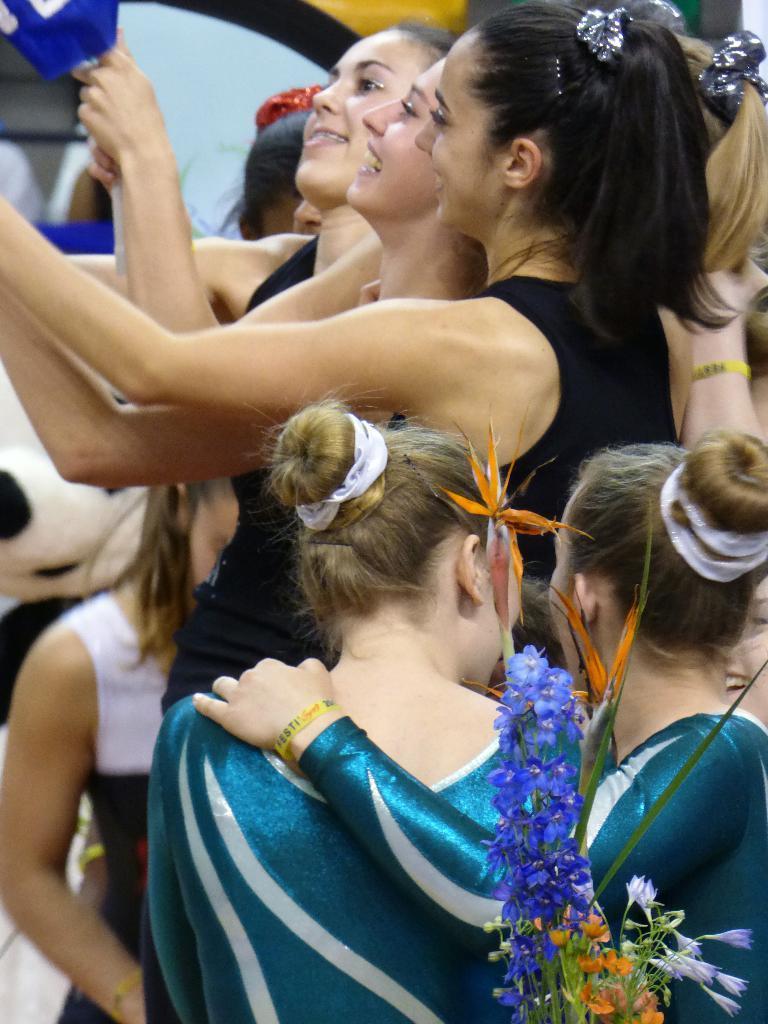In one or two sentences, can you explain what this image depicts? In this image there are decorative items , and at the background there are group of people standing. 